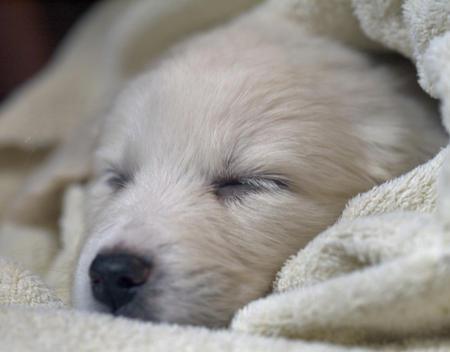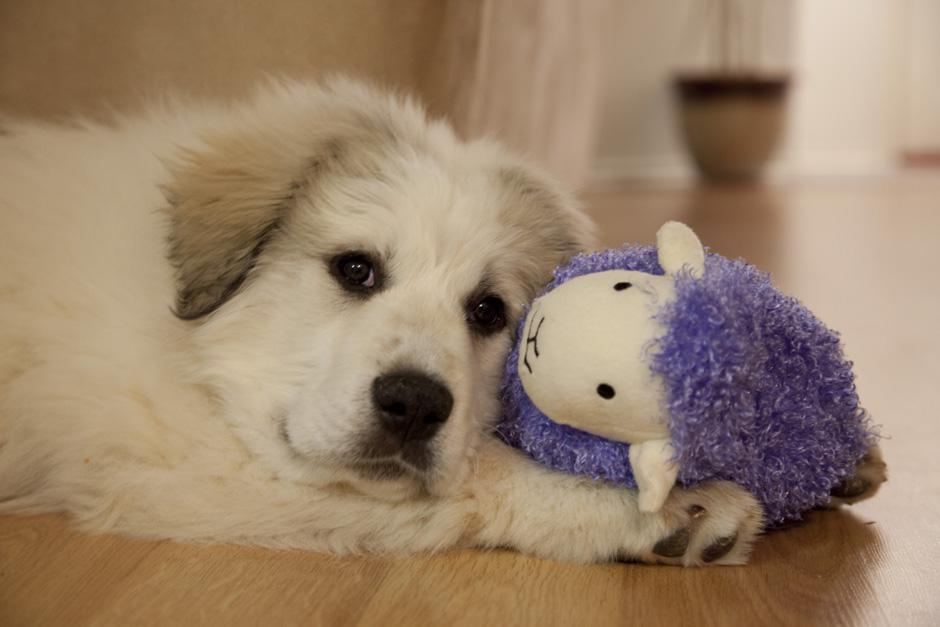The first image is the image on the left, the second image is the image on the right. Analyze the images presented: Is the assertion "One of the pictures shows a puppy sleeping alone." valid? Answer yes or no. Yes. The first image is the image on the left, the second image is the image on the right. Evaluate the accuracy of this statement regarding the images: "One image shows a single reclining white puppy with at least one front paw forward, and the other image shows a white dog reclining with a 'real' sleeping hooved animal.". Is it true? Answer yes or no. No. 